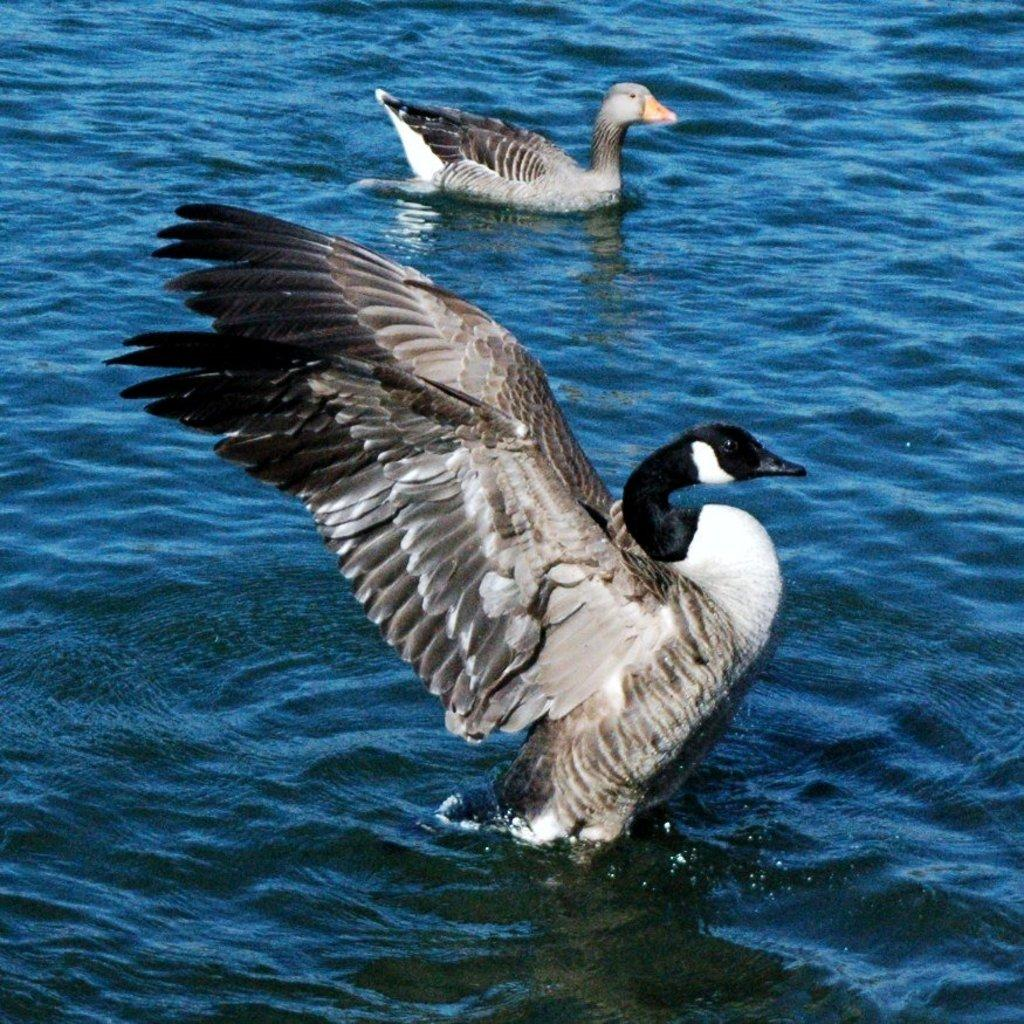What type of animals can be seen in the image? Birds can be seen in the image. Where are the birds located in the image? The birds are on the surface of the water. What type of powder can be seen floating on the lake in the image? There is no powder or lake present in the image; it features birds on the surface of the water. 